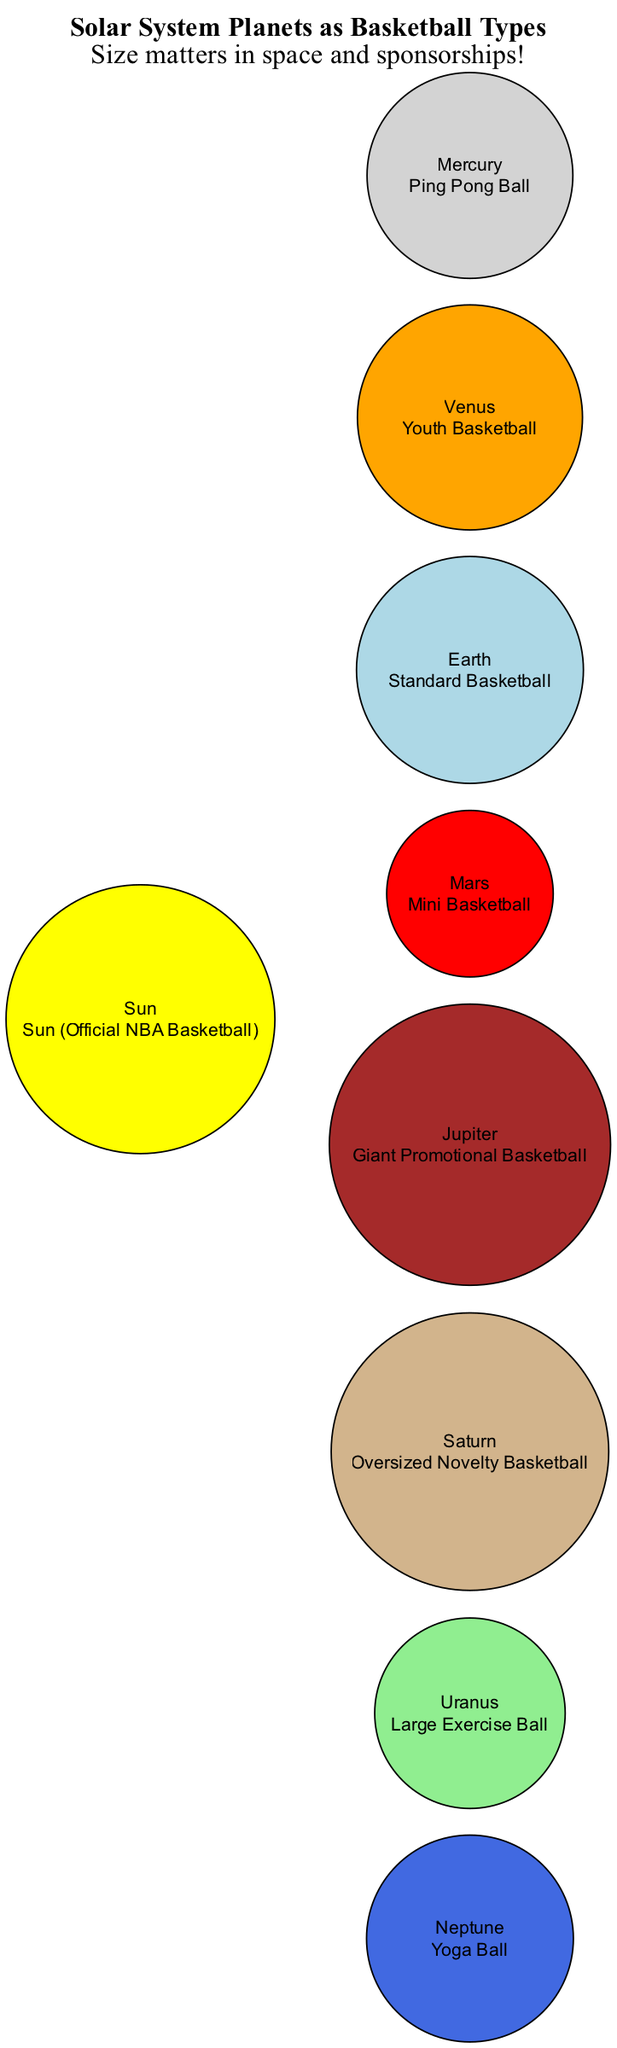What is the comparison for Jupiter? The diagram indicates that Jupiter is compared to a "Giant Promotional Basketball." This is obtained by locating Jupiter in the planets list and reading its corresponding comparison value.
Answer: Giant Promotional Basketball Which planet is represented as a Yoga Ball? The diagram shows that Neptune is represented as a "Yoga Ball." This is determined by finding Neptune in the planets section of the diagram and checking its comparison.
Answer: Yoga Ball How many planets are included in this diagram? The diagram lists a total of eight planets: Mercury, Venus, Earth, Mars, Jupiter, Saturn, Uranus, and Neptune. Counting these entries provides the total.
Answer: 8 What type of basketball represents Earth? The diagram states that Earth is compared to a "Standard Basketball." This can be found directly next to the identification of Earth in the diagram.
Answer: Standard Basketball Which planet is the largest by comparison type? Jupiter is the largest planet in this diagram and is represented by a "Giant Promotional Basketball," which implies it is larger than others represented. This is identified by analyzing the basketball type associated with each planet.
Answer: Giant Promotional Basketball Which basketball type is the comparison for Mars? According to the diagram, Mars is compared to a "Mini Basketball." This information is obtained by locating Mars and reading its comparison property.
Answer: Mini Basketball How does Saturn's basketball size compare to Jupiter's? Saturn is represented as an "Oversized Novelty Basketball," which is smaller than the "Giant Promotional Basketball" used for Jupiter. By comparing the descriptions directly from the diagram, one can determine this difference.
Answer: Smaller What is the central object in the diagram? The central object in the diagram is the "Sun (Official NBA Basketball)." This is noted at the center of the diagram's layout.
Answer: Sun (Official NBA Basketball) Which basketball type is used for Venus? The diagram indicates that Venus is compared to a "Youth Basketball." This is located next to Venus in the planets list on the diagram.
Answer: Youth Basketball 